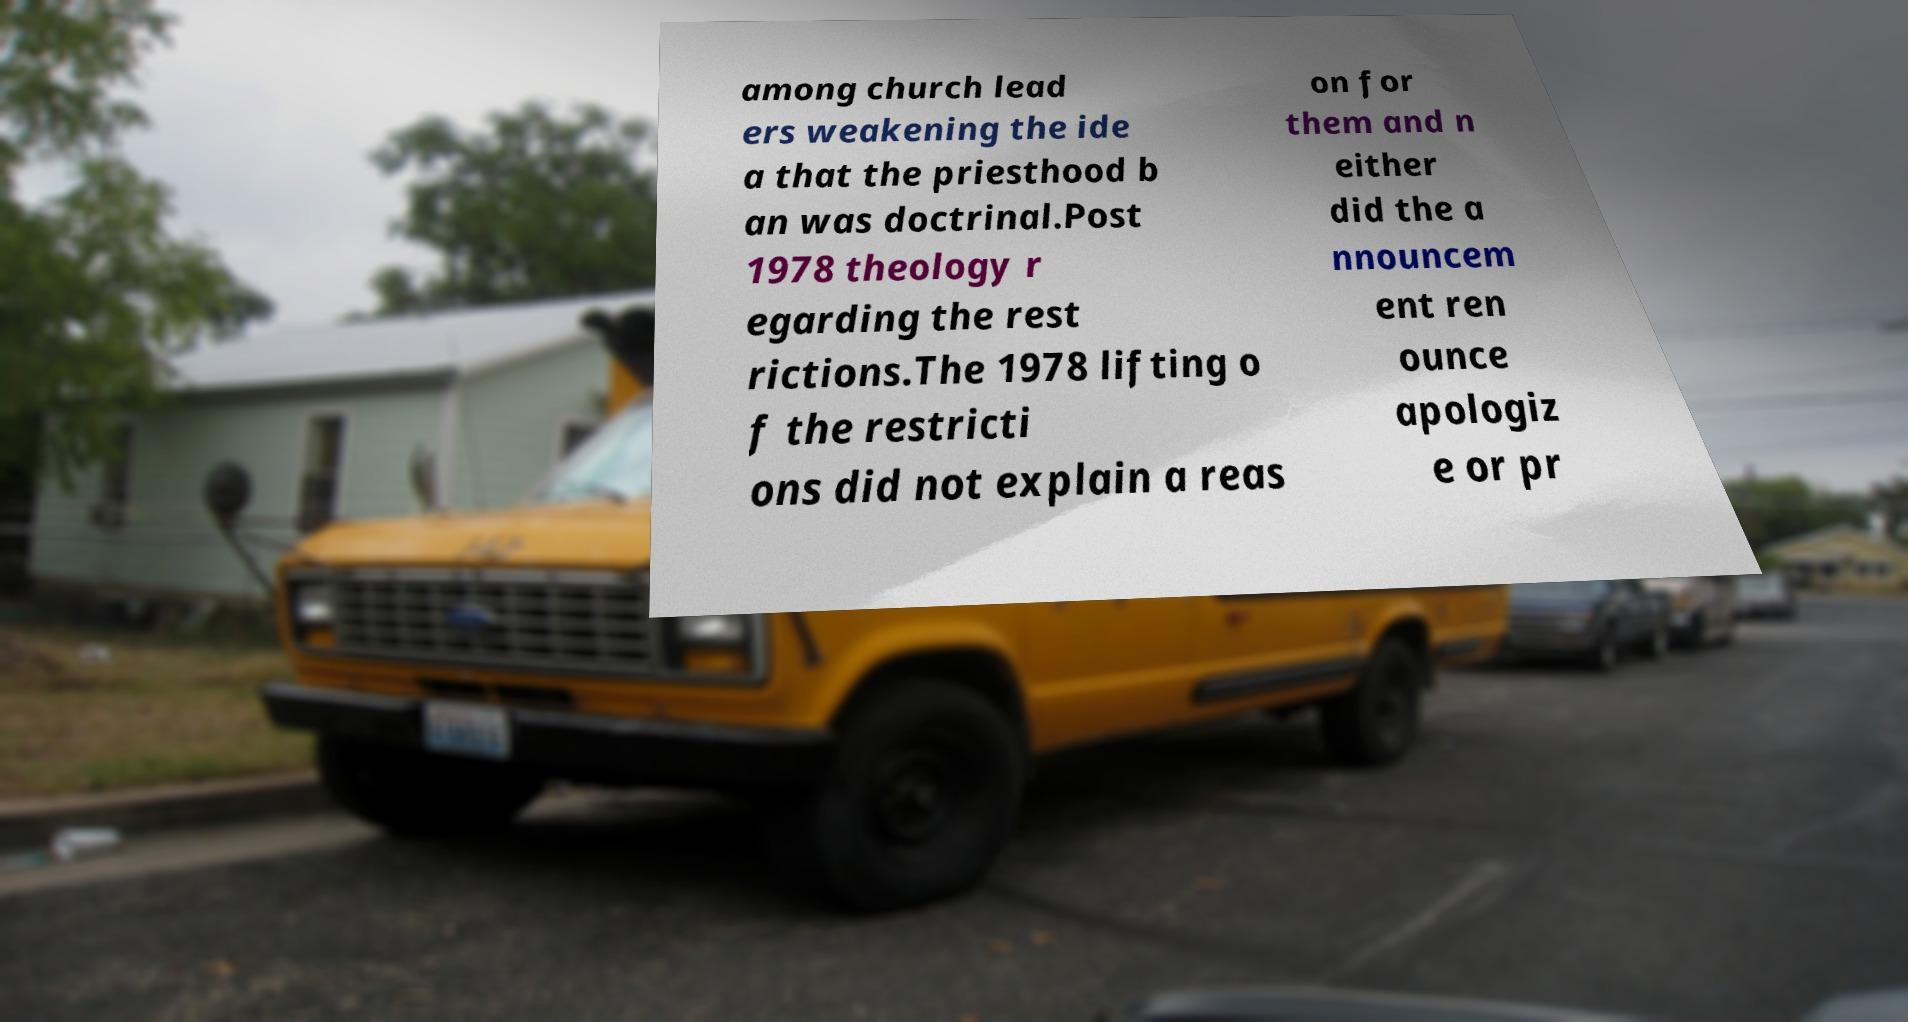Please identify and transcribe the text found in this image. among church lead ers weakening the ide a that the priesthood b an was doctrinal.Post 1978 theology r egarding the rest rictions.The 1978 lifting o f the restricti ons did not explain a reas on for them and n either did the a nnouncem ent ren ounce apologiz e or pr 